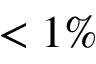<formula> <loc_0><loc_0><loc_500><loc_500>< 1 \%</formula> 